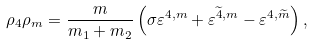<formula> <loc_0><loc_0><loc_500><loc_500>\rho _ { 4 } \rho _ { m } = \frac { m } { m _ { 1 } + m _ { 2 } } \left ( \sigma \varepsilon ^ { 4 , m } + \varepsilon ^ { \widetilde { 4 } , m } - \varepsilon ^ { 4 , \widetilde { m } } \right ) ,</formula> 